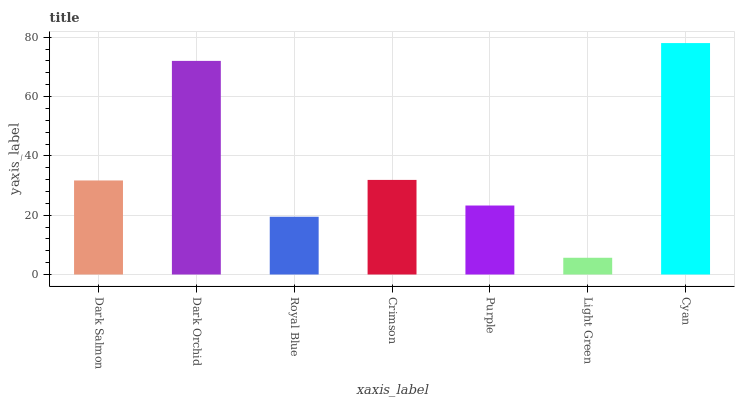Is Light Green the minimum?
Answer yes or no. Yes. Is Cyan the maximum?
Answer yes or no. Yes. Is Dark Orchid the minimum?
Answer yes or no. No. Is Dark Orchid the maximum?
Answer yes or no. No. Is Dark Orchid greater than Dark Salmon?
Answer yes or no. Yes. Is Dark Salmon less than Dark Orchid?
Answer yes or no. Yes. Is Dark Salmon greater than Dark Orchid?
Answer yes or no. No. Is Dark Orchid less than Dark Salmon?
Answer yes or no. No. Is Dark Salmon the high median?
Answer yes or no. Yes. Is Dark Salmon the low median?
Answer yes or no. Yes. Is Dark Orchid the high median?
Answer yes or no. No. Is Light Green the low median?
Answer yes or no. No. 